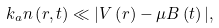Convert formula to latex. <formula><loc_0><loc_0><loc_500><loc_500>k _ { a } n \left ( { r } , t \right ) \ll | V \left ( { r } \right ) - \mu B \left ( t \right ) | ,</formula> 